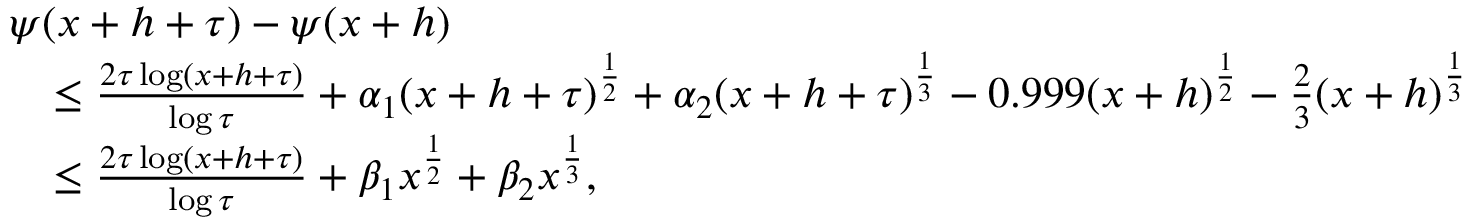<formula> <loc_0><loc_0><loc_500><loc_500>\begin{array} { r l } & { \psi ( x + h + \tau ) - \psi ( x + h ) } \\ & { \quad \leq \frac { 2 \tau \log ( x + h + \tau ) } { \log { \tau } } + \alpha _ { 1 } ( x + h + \tau ) ^ { \frac { 1 } { 2 } } + \alpha _ { 2 } ( x + h + \tau ) ^ { \frac { 1 } { 3 } } - 0 . 9 9 9 ( x + h ) ^ { \frac { 1 } { 2 } } - \frac { 2 } { 3 } ( x + h ) ^ { \frac { 1 } { 3 } } } \\ & { \quad \leq \frac { 2 \tau \log ( x + h + \tau ) } { \log { \tau } } + \beta _ { 1 } x ^ { \frac { 1 } { 2 } } + \beta _ { 2 } x ^ { \frac { 1 } { 3 } } , } \end{array}</formula> 